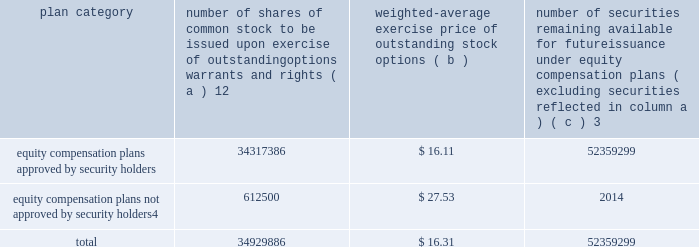Part iii item 10 .
Directors , executive officers and corporate governance the information required by this item is incorporated by reference to the 201celection of directors 201d section , the 201cdirector selection process 201d section , the 201ccode of conduct 201d section , the 201cprincipal committees of the board of directors 201d section , the 201caudit committee 201d section and the 201csection 16 ( a ) beneficial ownership reporting compliance 201d section of the proxy statement for the annual meeting of stockholders to be held on may 27 , 2010 ( the 201cproxy statement 201d ) , except for the description of our executive officers , which appears in part i of this report on form 10-k under the heading 201cexecutive officers of ipg . 201d new york stock exchange certification in 2009 , our ceo provided the annual ceo certification to the new york stock exchange , as required under section 303a.12 ( a ) of the new york stock exchange listed company manual .
Item 11 .
Executive compensation the information required by this item is incorporated by reference to the 201ccompensation of executive officers 201d section , the 201cnon-management director compensation 201d section , the 201ccompensation discussion and analysis 201d section and the 201ccompensation committee report 201d section of the proxy statement .
Item 12 .
Security ownership of certain beneficial owners and management and related stockholder matters the information required by this item is incorporated by reference to the 201coutstanding shares 201d section of the proxy statement , except for information regarding the shares of common stock to be issued or which may be issued under our equity compensation plans as of december 31 , 2009 , which is provided in the table .
Equity compensation plan information plan category number of shares of common stock to be issued upon exercise of outstanding options , warrants and rights ( a ) 12 weighted-average exercise price of outstanding stock options ( b ) number of securities remaining available for future issuance under equity compensation plans ( excluding securities reflected in column a ) ( c ) 3 equity compensation plans approved by security holders .
34317386 $ 16.11 52359299 equity compensation plans not approved by security holders 4 .
612500 $ 27.53 2014 .
1 includes a total of 6058967 performance-based share awards made under the 2004 , 2006 and 2009 performance incentive plan representing the target number of shares to be issued to employees following the completion of the 2007-2009 performance period ( the 201c2009 ltip share awards 201d ) , the 2008- 2010 performance period ( the 201c2010 ltip share awards 201d ) and the 2009-2011 performance period ( the 201c2011 ltip share awards 201d ) respectively .
The computation of the weighted-average exercise price in column ( b ) of this table does not take the 2009 ltip share awards , the 2010 ltip share awards or the 2011 ltip share awards into account .
2 includes a total of 3914804 restricted share unit and performance-based awards ( 201cshare unit awards 201d ) which may be settled in shares or cash .
The computation of the weighted-average exercise price in column ( b ) of this table does not take the share unit awards into account .
Each share unit award actually settled in cash will increase the number of shares of common stock available for issuance shown in column ( c ) .
3 includes ( i ) 37885502 shares of common stock available for issuance under the 2009 performance incentive plan , ( ii ) 13660306 shares of common stock available for issuance under the employee stock purchase plan ( 2006 ) and ( iii ) 813491 shares of common stock available for issuance under the 2009 non-management directors 2019 stock incentive plan .
4 consists of special stock option grants awarded to certain true north executives following our acquisition of true north ( the 201ctrue north options 201d ) .
The true north options have an exercise price equal to the fair market value of interpublic 2019s common stock on the date of the grant .
The terms and conditions of these stock option awards are governed by interpublic 2019s 1997 performance incentive plan .
Generally , the options become exercisable between two and five years after the date of the grant and expire ten years from the grant date. .
What was the total cost of all shares of common stock upon the exercise of outstanding stock options that were approved by security holders? 
Computations: (34317386 * 16.11)
Answer: 552853088.46. 